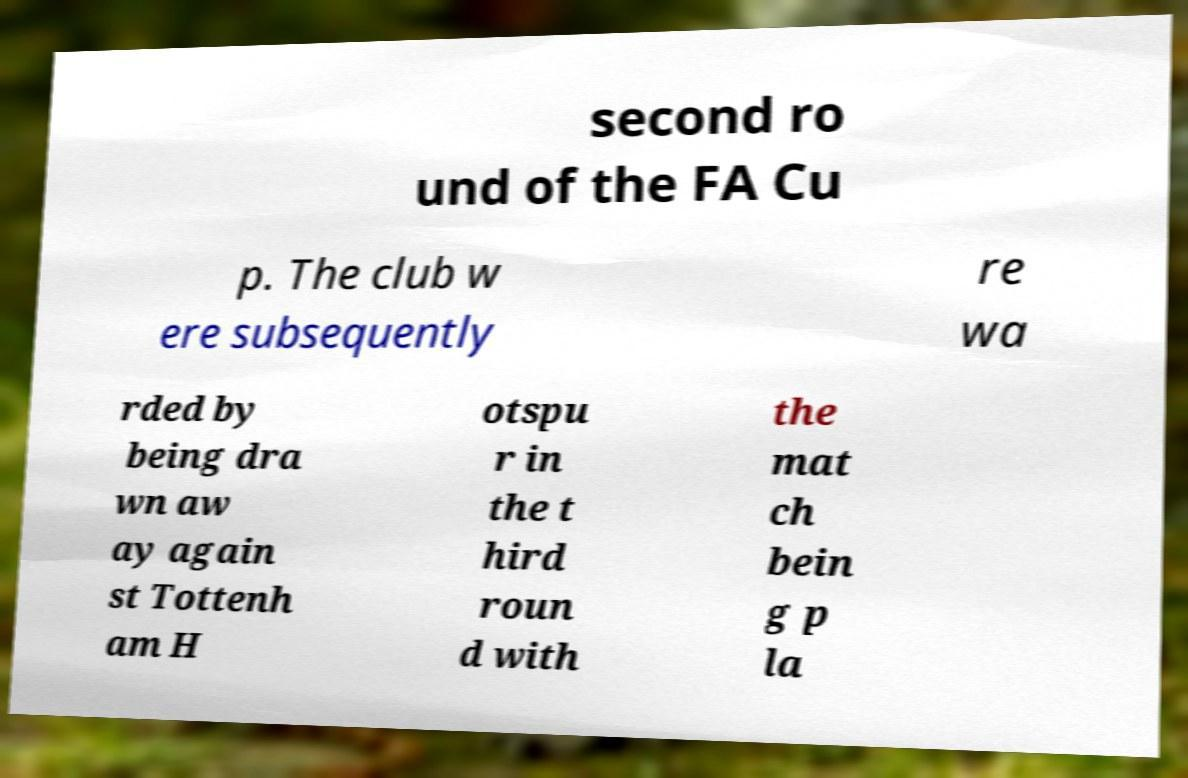What messages or text are displayed in this image? I need them in a readable, typed format. second ro und of the FA Cu p. The club w ere subsequently re wa rded by being dra wn aw ay again st Tottenh am H otspu r in the t hird roun d with the mat ch bein g p la 